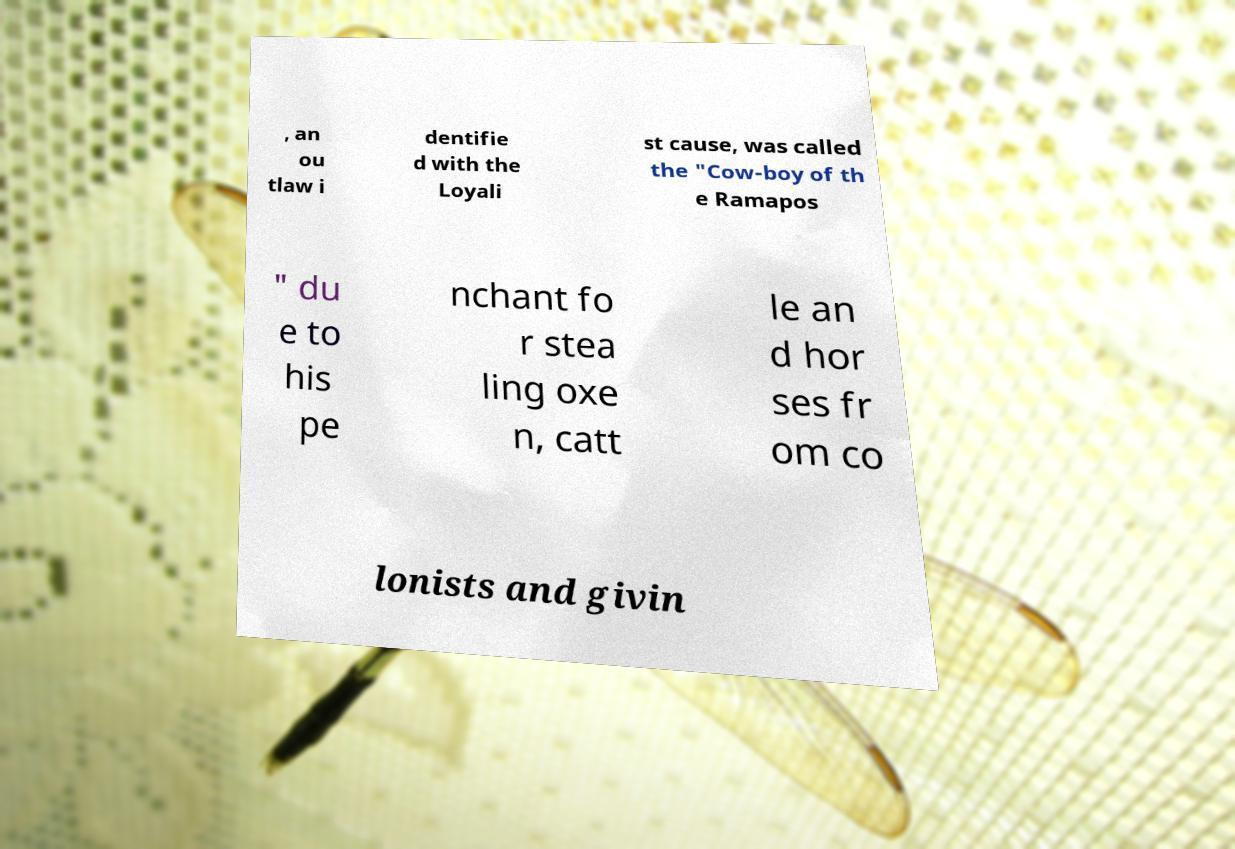Can you accurately transcribe the text from the provided image for me? , an ou tlaw i dentifie d with the Loyali st cause, was called the "Cow-boy of th e Ramapos " du e to his pe nchant fo r stea ling oxe n, catt le an d hor ses fr om co lonists and givin 